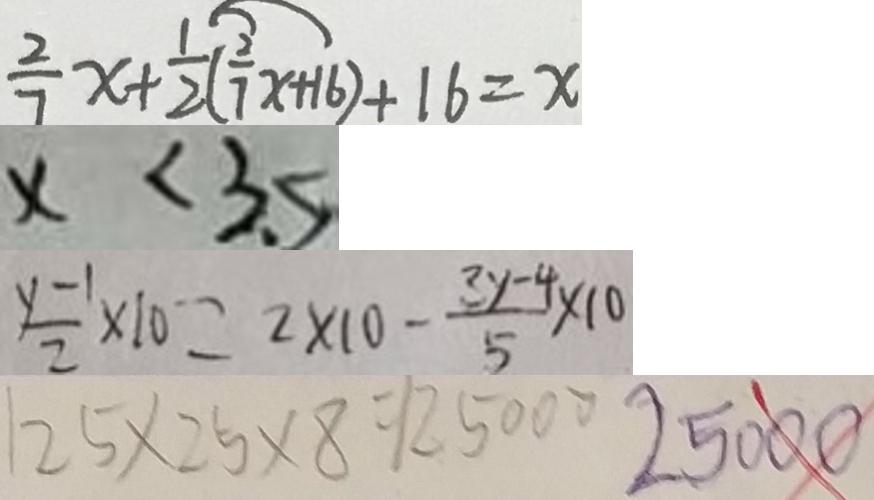Convert formula to latex. <formula><loc_0><loc_0><loc_500><loc_500>\frac { 2 } { 7 } x + \frac { 1 } { 2 } ( \frac { 2 } { 7 } x + 1 6 ) + 1 6 = x 
 \times < 3 5 
 \frac { y - 1 } { 2 } \times 1 0 = 2 \times 1 0 - \frac { 3 y - 4 } { 5 } \times 1 0 
 2 5 \times 2 5 \times 8 = 1 2 5 0 0 0 2 5 0 0 0</formula> 